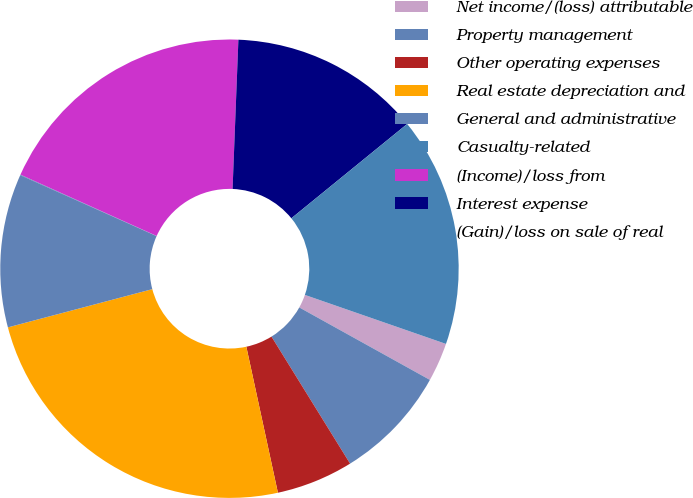Convert chart to OTSL. <chart><loc_0><loc_0><loc_500><loc_500><pie_chart><fcel>Net income/(loss) attributable<fcel>Property management<fcel>Other operating expenses<fcel>Real estate depreciation and<fcel>General and administrative<fcel>Casualty-related<fcel>(Income)/loss from<fcel>Interest expense<fcel>(Gain)/loss on sale of real<nl><fcel>2.74%<fcel>8.12%<fcel>5.43%<fcel>24.27%<fcel>10.81%<fcel>0.04%<fcel>18.89%<fcel>13.5%<fcel>16.2%<nl></chart> 